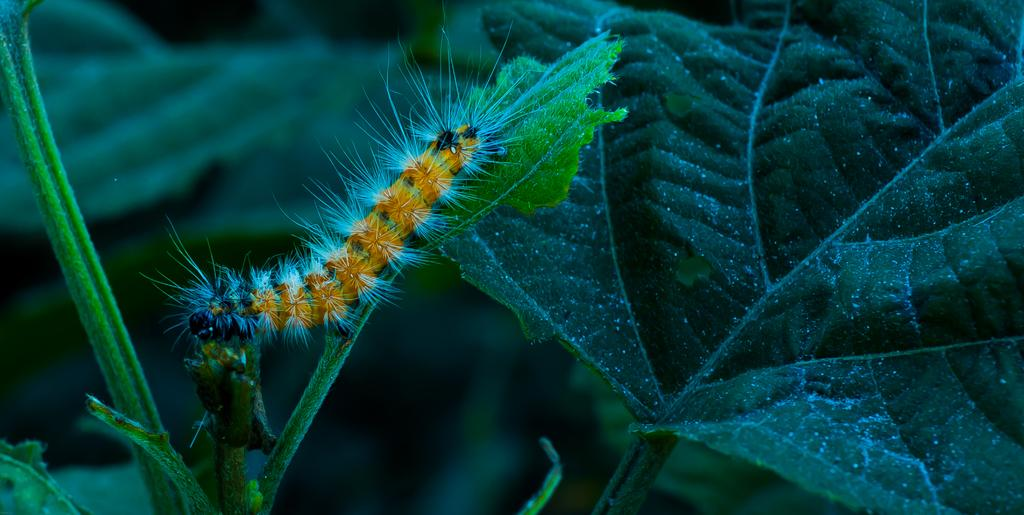What type of natural elements can be seen in the image? There are leaves in the image. Can you describe the insect in the image? There is an insect present on a stem in the image. What can be seen in the background of the image? There is greenery in the background of the image. What type of structure can be seen in the image? There is no structure present in the image; it primarily features natural elements such as leaves and an insect. How many snails are visible in the image? There are no snails present in the image. 